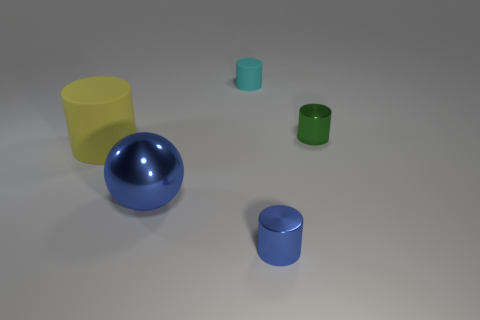Add 3 small cyan cylinders. How many objects exist? 8 Subtract all cylinders. How many objects are left? 1 Subtract 0 cyan blocks. How many objects are left? 5 Subtract all tiny cyan metal cylinders. Subtract all small green cylinders. How many objects are left? 4 Add 1 tiny cyan objects. How many tiny cyan objects are left? 2 Add 3 small purple rubber cylinders. How many small purple rubber cylinders exist? 3 